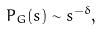<formula> <loc_0><loc_0><loc_500><loc_500>P _ { G } ( s ) \sim s ^ { - \delta } ,</formula> 